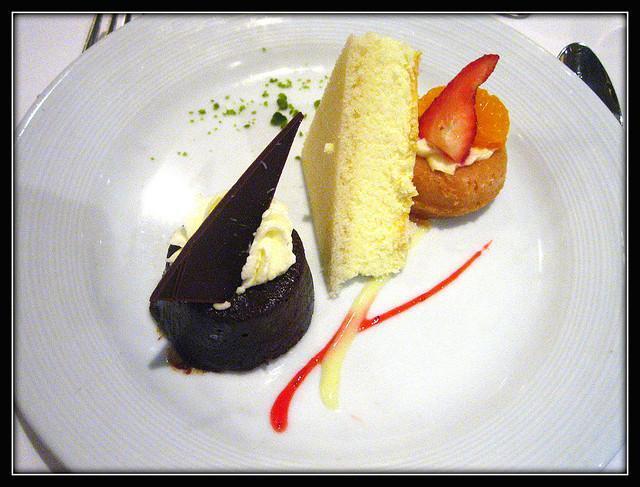How many cakes are there?
Give a very brief answer. 3. How many people are in the image?
Give a very brief answer. 0. 